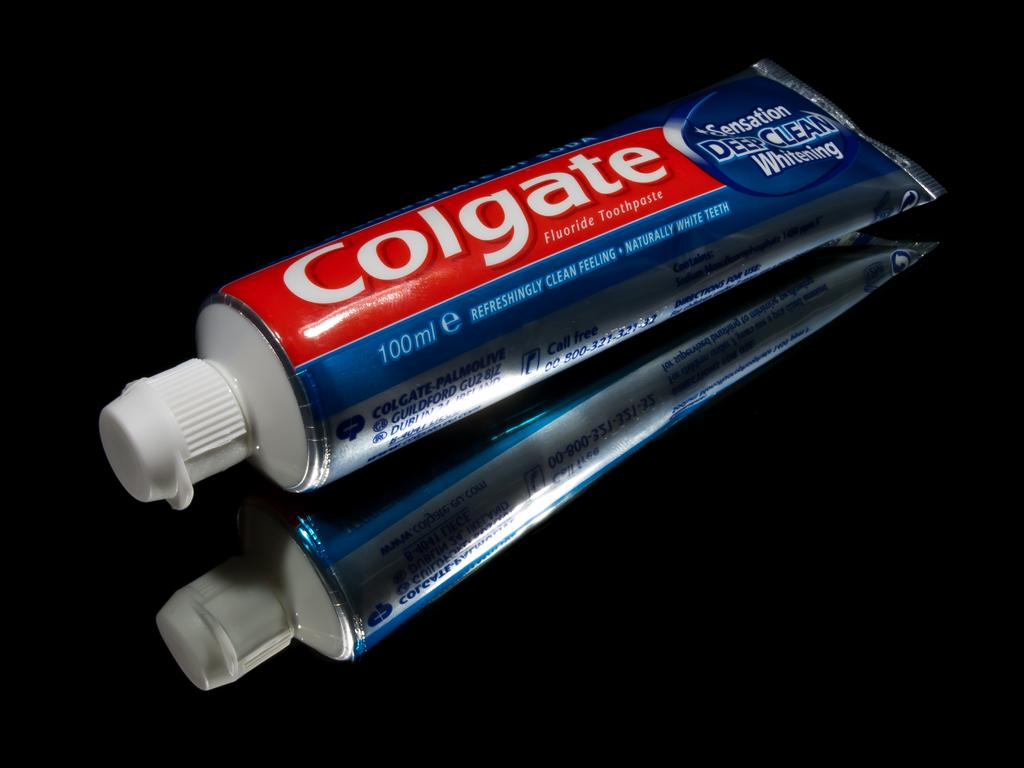Provide a one-sentence caption for the provided image. A tube of Colgate Deep Clean lyng on a black surface. 